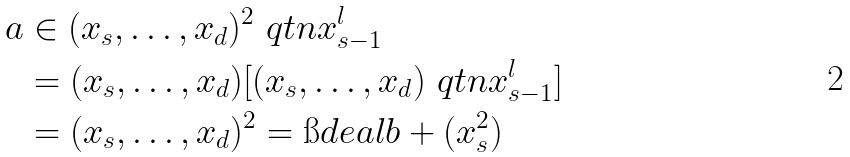Convert formula to latex. <formula><loc_0><loc_0><loc_500><loc_500>a & \in ( x _ { s } , \dots , x _ { d } ) ^ { 2 } \ q t n x _ { s - 1 } ^ { l } \\ & = ( x _ { s } , \dots , x _ { d } ) [ ( x _ { s } , \dots , x _ { d } ) \ q t n x _ { s - 1 } ^ { l } ] \\ & = ( x _ { s } , \dots , x _ { d } ) ^ { 2 } = \i d e a l b + ( x _ { s } ^ { 2 } )</formula> 